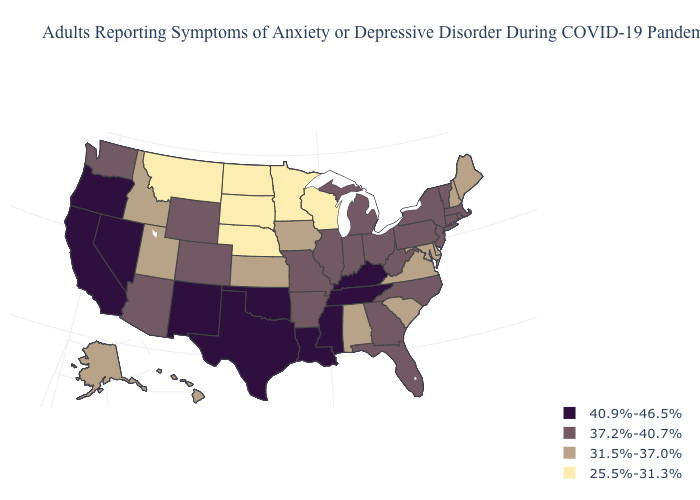What is the highest value in the West ?
Keep it brief. 40.9%-46.5%. What is the value of Wisconsin?
Quick response, please. 25.5%-31.3%. What is the lowest value in states that border Michigan?
Answer briefly. 25.5%-31.3%. Does the first symbol in the legend represent the smallest category?
Concise answer only. No. Does Oregon have the same value as Nevada?
Write a very short answer. Yes. Which states have the lowest value in the South?
Write a very short answer. Alabama, Delaware, Maryland, South Carolina, Virginia. What is the value of Alaska?
Give a very brief answer. 31.5%-37.0%. Does the first symbol in the legend represent the smallest category?
Answer briefly. No. What is the value of Oregon?
Answer briefly. 40.9%-46.5%. Name the states that have a value in the range 31.5%-37.0%?
Concise answer only. Alabama, Alaska, Delaware, Hawaii, Idaho, Iowa, Kansas, Maine, Maryland, New Hampshire, South Carolina, Utah, Virginia. What is the lowest value in states that border Nebraska?
Write a very short answer. 25.5%-31.3%. What is the value of Ohio?
Concise answer only. 37.2%-40.7%. Name the states that have a value in the range 31.5%-37.0%?
Concise answer only. Alabama, Alaska, Delaware, Hawaii, Idaho, Iowa, Kansas, Maine, Maryland, New Hampshire, South Carolina, Utah, Virginia. Name the states that have a value in the range 25.5%-31.3%?
Keep it brief. Minnesota, Montana, Nebraska, North Dakota, South Dakota, Wisconsin. Which states have the lowest value in the USA?
Be succinct. Minnesota, Montana, Nebraska, North Dakota, South Dakota, Wisconsin. 